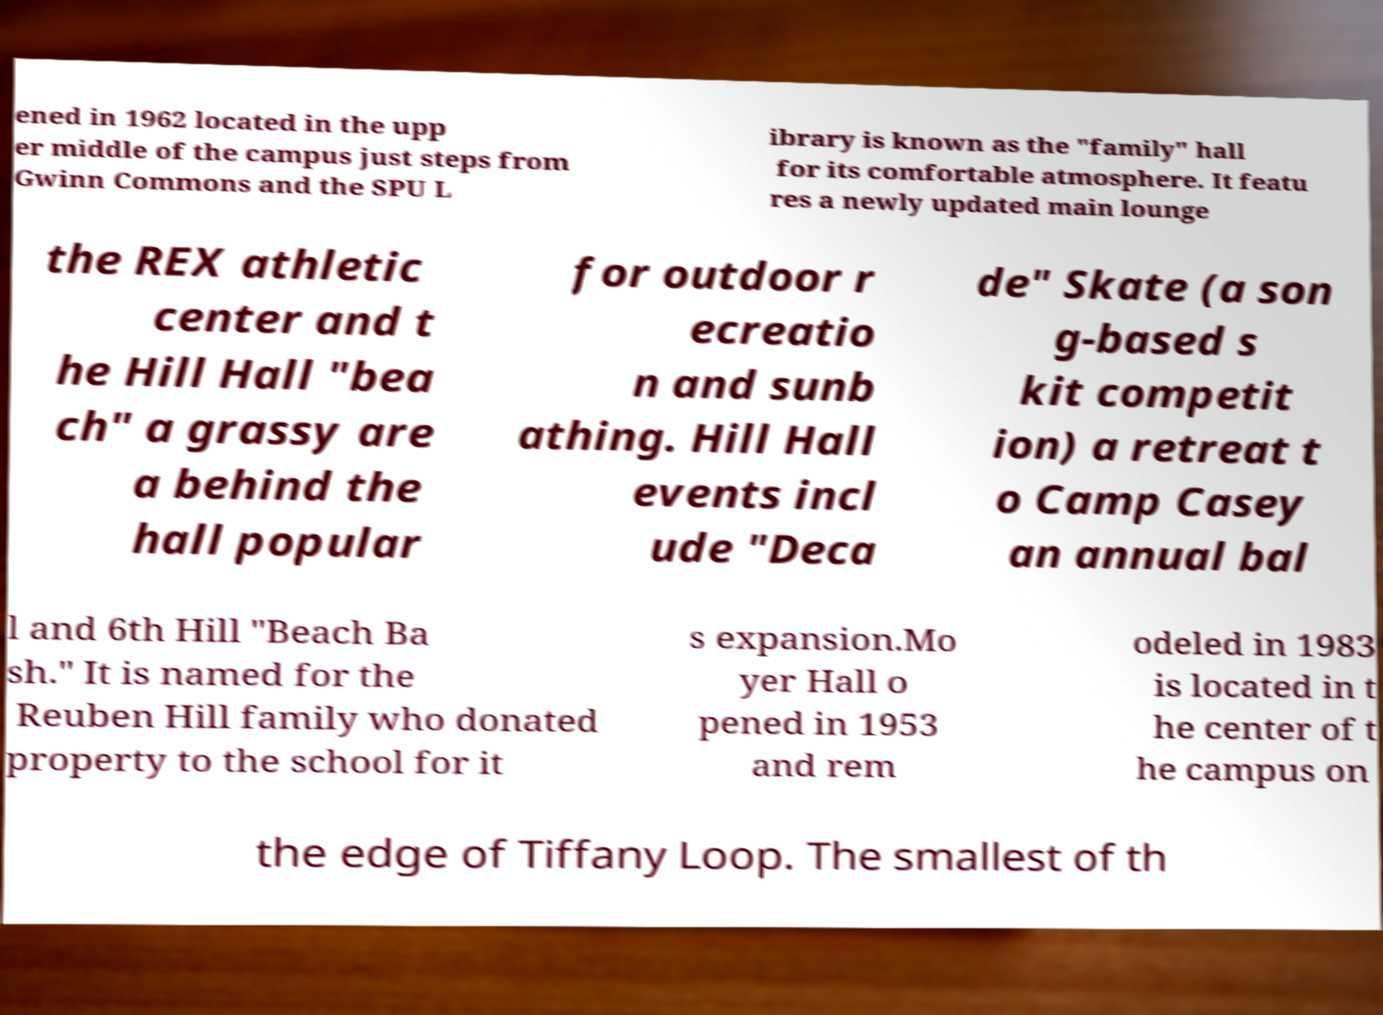Can you read and provide the text displayed in the image?This photo seems to have some interesting text. Can you extract and type it out for me? ened in 1962 located in the upp er middle of the campus just steps from Gwinn Commons and the SPU L ibrary is known as the "family" hall for its comfortable atmosphere. It featu res a newly updated main lounge the REX athletic center and t he Hill Hall "bea ch" a grassy are a behind the hall popular for outdoor r ecreatio n and sunb athing. Hill Hall events incl ude "Deca de" Skate (a son g-based s kit competit ion) a retreat t o Camp Casey an annual bal l and 6th Hill "Beach Ba sh." It is named for the Reuben Hill family who donated property to the school for it s expansion.Mo yer Hall o pened in 1953 and rem odeled in 1983 is located in t he center of t he campus on the edge of Tiffany Loop. The smallest of th 